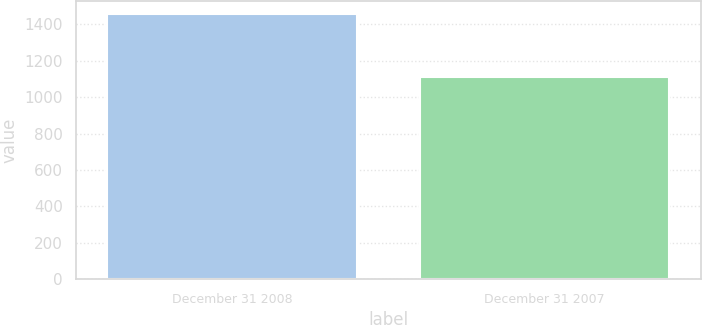Convert chart to OTSL. <chart><loc_0><loc_0><loc_500><loc_500><bar_chart><fcel>December 31 2008<fcel>December 31 2007<nl><fcel>1455<fcel>1108<nl></chart> 